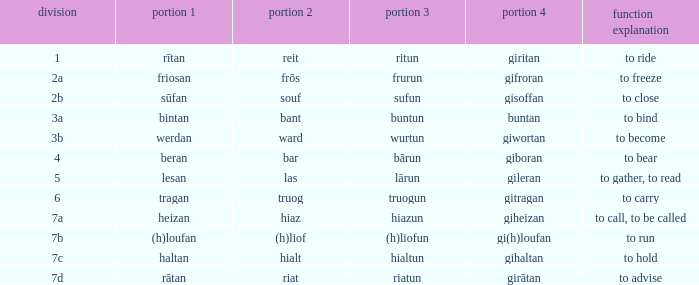What is the part 4 of the word with the part 1 "heizan"? Giheizan. 